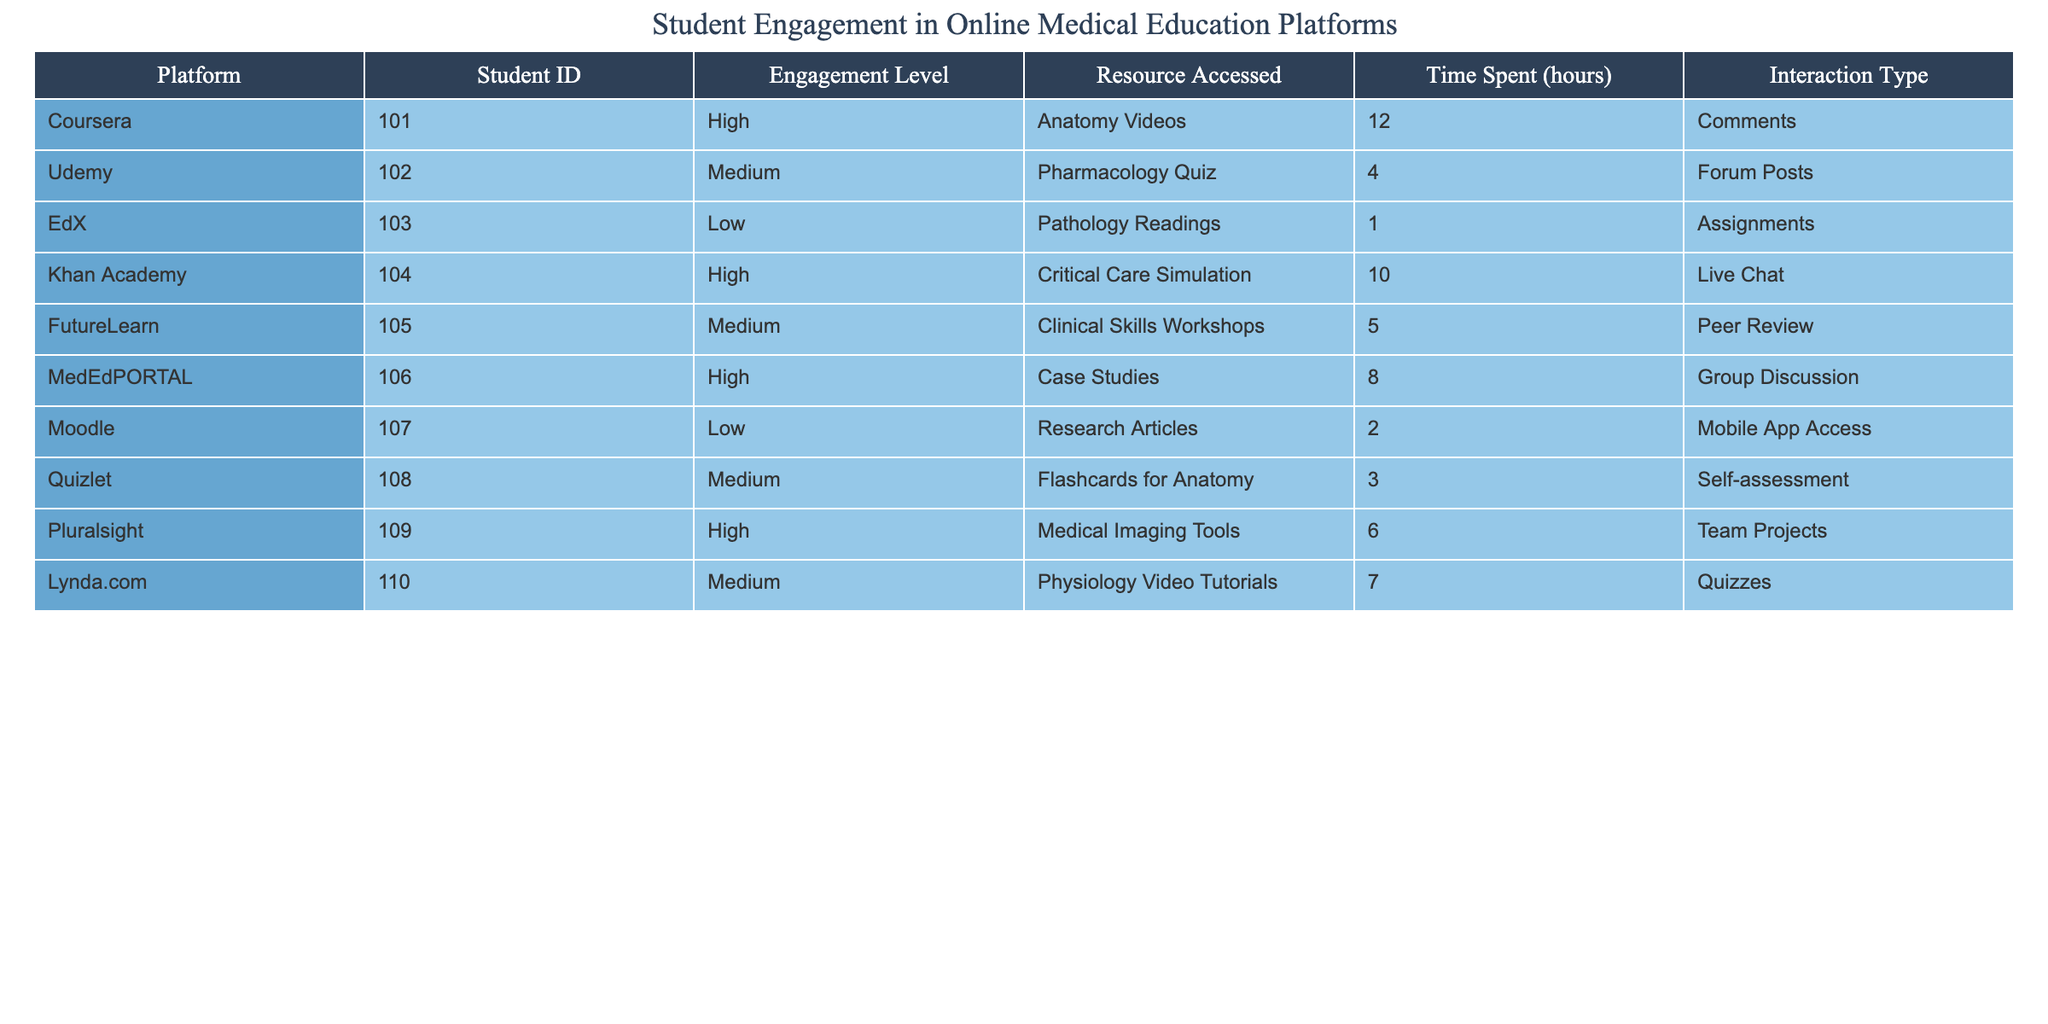What is the engagement level of the student using Udemy? Udemy is listed in the table, and it shows an engagement level of "Medium."
Answer: Medium How many hours did the student with the highest engagement level spend on the platform? The highest engagement level is "High," which can be found for Coursera, Khan Academy, MedEdPORTAL, and Pluralsight. The maximum time spent is 12 hours (Coursera).
Answer: 12 hours Which platform had the lowest engagement level? The platform with the lowest engagement level is EdX, which is categorized as "Low."
Answer: EdX What is the average time spent by students with a medium engagement level? The students with a medium engagement level are from Udemy, FutureLearn, Quizlet, and Lynda.com. Their times spent are 4, 5, 3, and 7 hours respectively. The total is 4 + 5 + 3 + 7 = 19 hours. There are 4 students, so the average is 19/4 = 4.75 hours.
Answer: 4.75 hours Did any students engage with live chat? The table shows that only Khan Academy had the interaction type "Live Chat."
Answer: Yes Which interaction type was most frequently used among high engagement students? The interaction types for high engagement students are Comments (Coursera), Live Chat (Khan Academy), Group Discussion (MedEdPORTAL), and Team Projects (Pluralsight). The most common type among these is "Comments."
Answer: Comments How many total hours did students who accessed physiology resources spend? The only student who accessed physiology resources is from Lynda.com, who spent 7 hours on it.
Answer: 7 hours What is the difference in time spent between the highest and lowest engagement level? The highest engagement level is 12 hours (Coursera), and the lowest is 1 hour (EdX). The difference is 12 - 1 = 11 hours.
Answer: 11 hours Which platform had the most hours spent by students overall? By calculating the hours for all platforms, Coursera (12), Khan Academy (10), MedEdPORTAL (8), and Pluralsight (6) had the highest at 12 hours.
Answer: Coursera Do all platforms show a range of engagement levels? Yes, the table displays all three engagement levels: High, Medium, and Low across the platforms listed.
Answer: Yes 